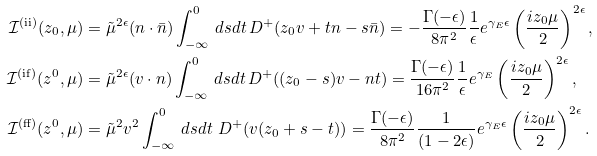Convert formula to latex. <formula><loc_0><loc_0><loc_500><loc_500>\mathcal { I } ^ { ( \text {ii} ) } ( z _ { 0 } , \mu ) & = \tilde { \mu } ^ { 2 \epsilon } ( n \cdot \bar { n } ) \int _ { - \infty } ^ { 0 } \, d s d t \, D ^ { + } ( z _ { 0 } v + t n - s \bar { n } ) = - \frac { \Gamma ( - \epsilon ) } { 8 \pi ^ { 2 } } \frac { 1 } { \epsilon } e ^ { \gamma _ { E } \epsilon } \left ( \frac { i z _ { 0 } \mu } { 2 } \right ) ^ { 2 \epsilon } , \\ \mathcal { I } ^ { \text {(if)} } ( z ^ { 0 } , \mu ) & = \tilde { \mu } ^ { 2 \epsilon } ( v \cdot n ) \int _ { - \infty } ^ { 0 } \, d s d t \, D ^ { + } ( ( z _ { 0 } - s ) v - n t ) = \frac { \Gamma ( - \epsilon ) } { 1 6 \pi ^ { 2 } } \frac { 1 } { \epsilon } e ^ { \gamma _ { E } } \left ( \frac { i z _ { 0 } \mu } { 2 } \right ) ^ { 2 \epsilon } , \\ \mathcal { I } ^ { ( \text {ff} ) } ( z ^ { 0 } , \mu ) & = \tilde { \mu } ^ { 2 } v ^ { 2 } \int _ { - \infty } ^ { 0 } \, d s d t \ D ^ { + } ( v ( z _ { 0 } + s - t ) ) = \frac { \Gamma ( - \epsilon ) } { 8 \pi ^ { 2 } } \frac { 1 } { ( 1 - 2 \epsilon ) } e ^ { \gamma _ { E } \epsilon } \left ( \frac { i z _ { 0 } \mu } { 2 } \right ) ^ { 2 \epsilon } .</formula> 